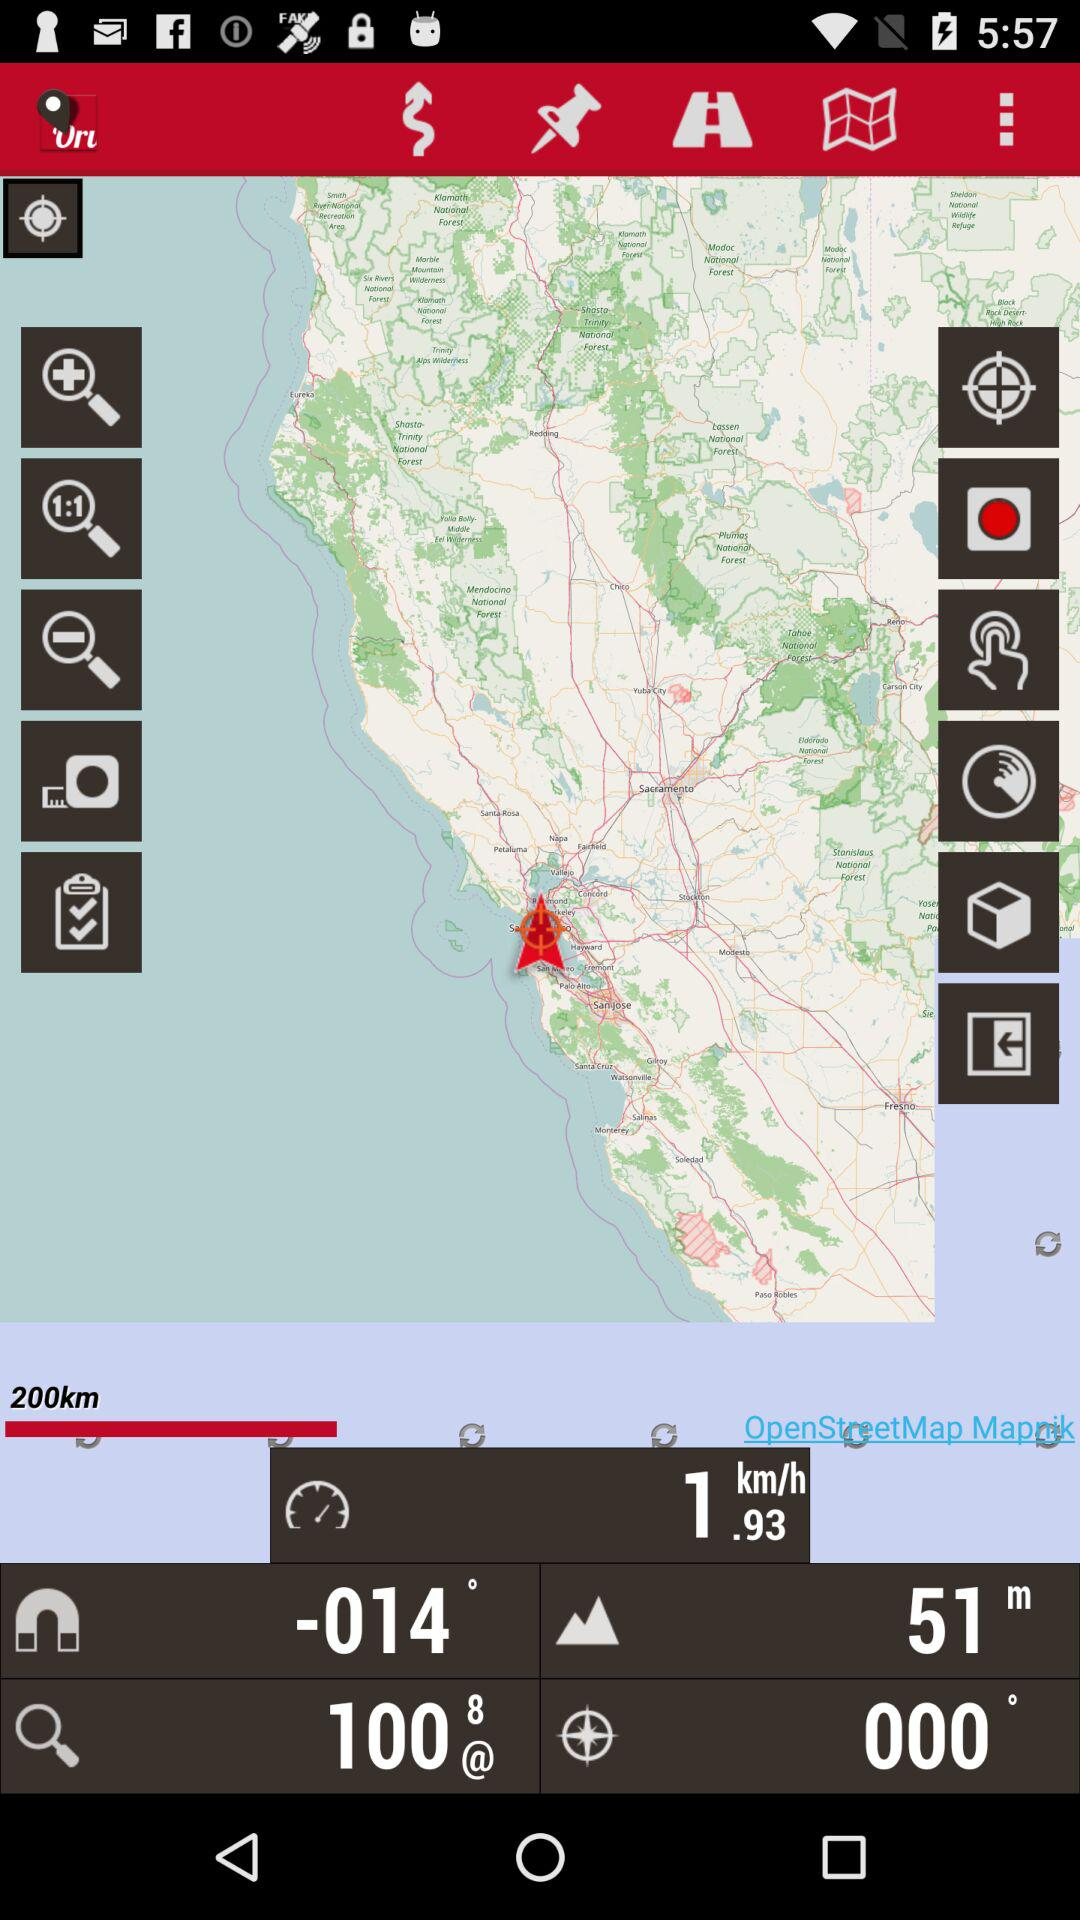What are some significant natural landmarks near this area? Near this area is the famous Golden Gate Bridge, Alcatraz Island, and the expansive Muir Woods National Monument, known for its towering old-growth redwood trees. 